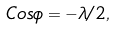<formula> <loc_0><loc_0><loc_500><loc_500>C o s \phi = - \lambda / 2 ,</formula> 